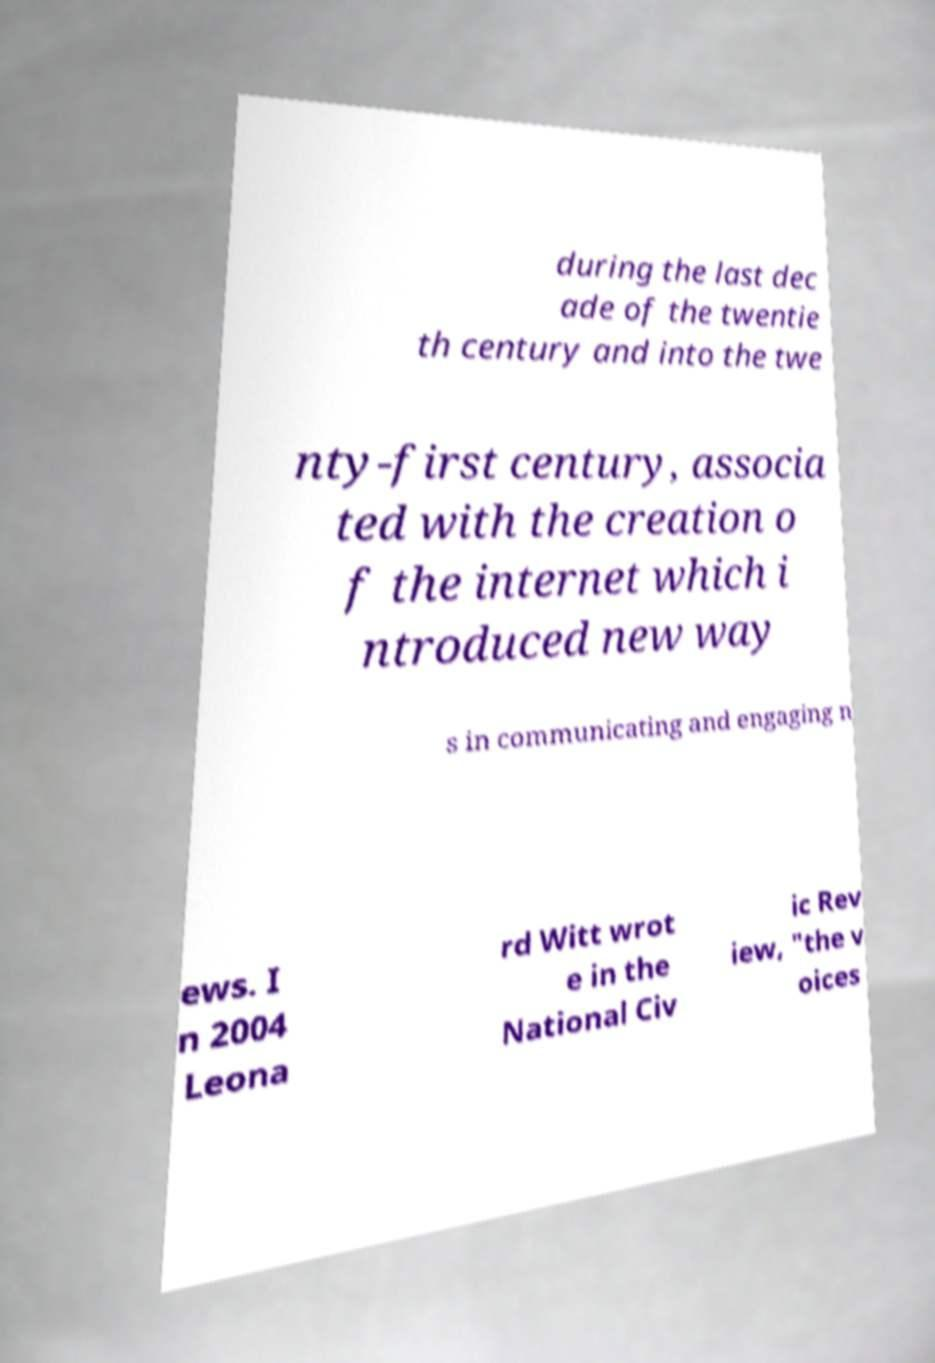I need the written content from this picture converted into text. Can you do that? during the last dec ade of the twentie th century and into the twe nty-first century, associa ted with the creation o f the internet which i ntroduced new way s in communicating and engaging n ews. I n 2004 Leona rd Witt wrot e in the National Civ ic Rev iew, "the v oices 